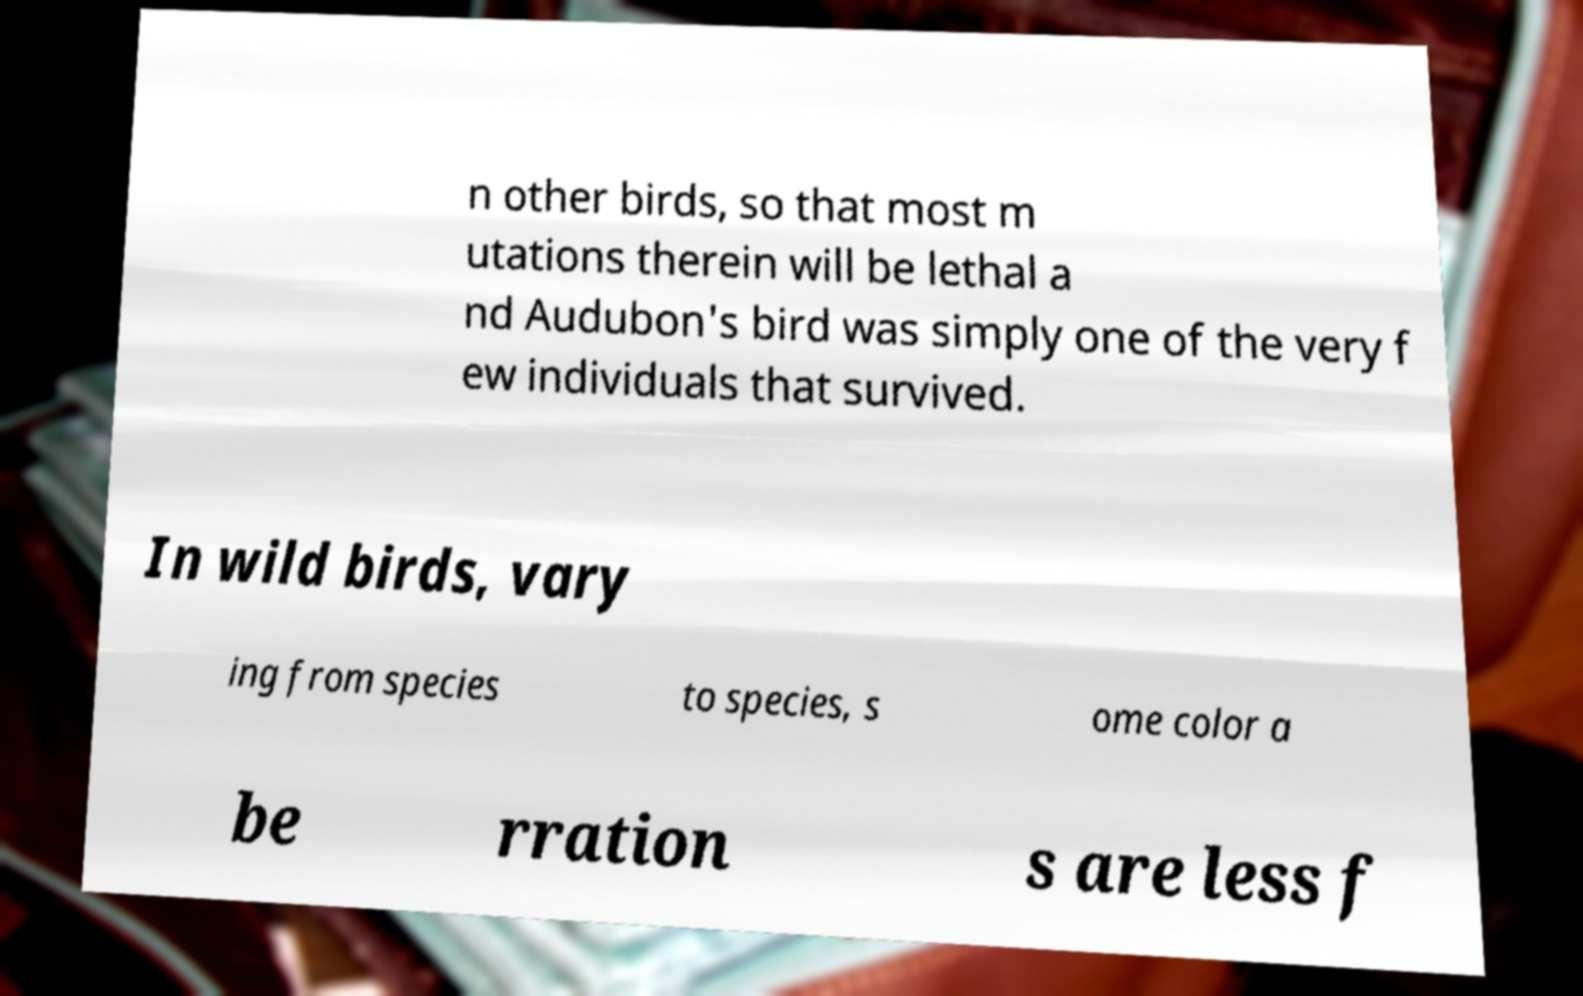What messages or text are displayed in this image? I need them in a readable, typed format. n other birds, so that most m utations therein will be lethal a nd Audubon's bird was simply one of the very f ew individuals that survived. In wild birds, vary ing from species to species, s ome color a be rration s are less f 